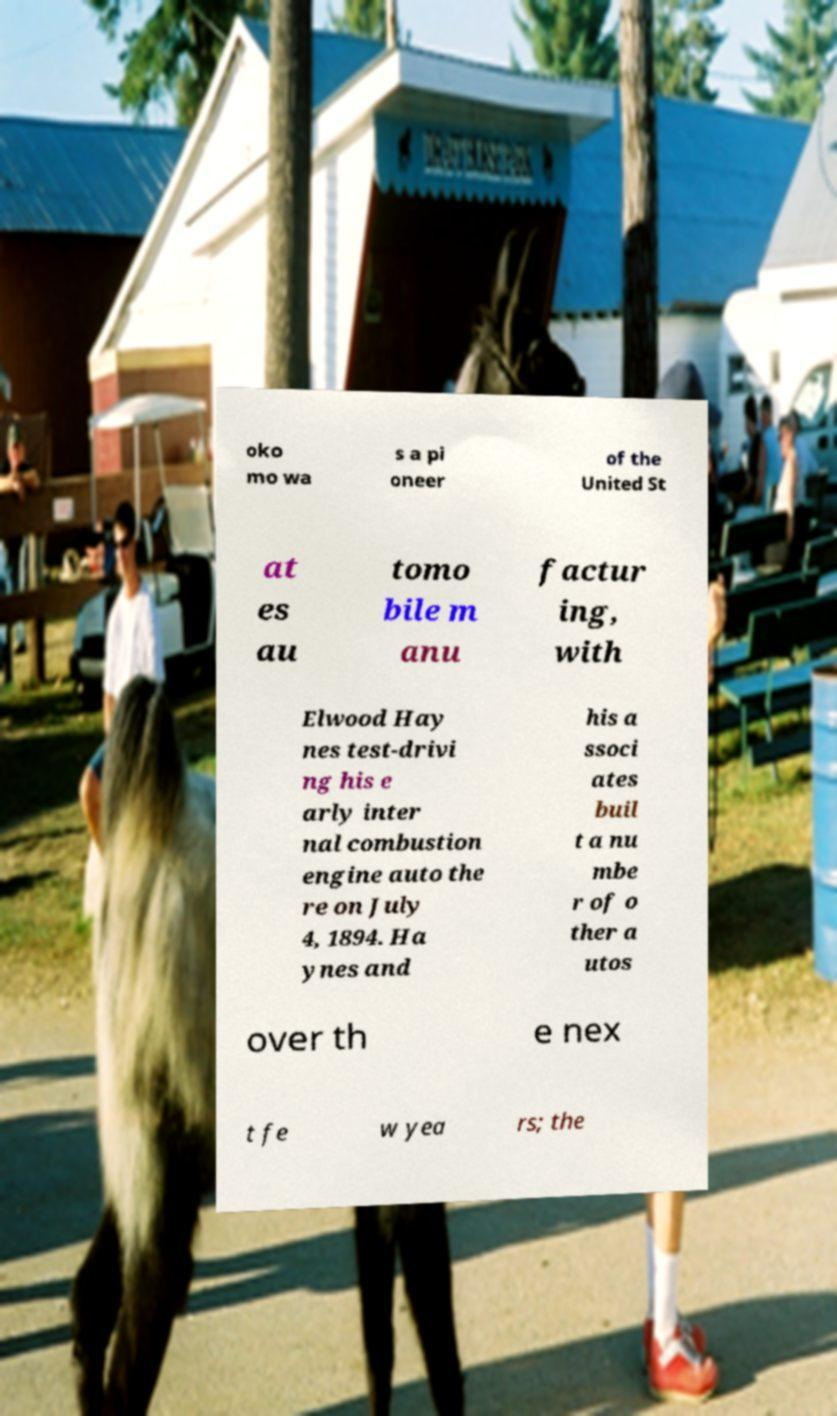Can you accurately transcribe the text from the provided image for me? oko mo wa s a pi oneer of the United St at es au tomo bile m anu factur ing, with Elwood Hay nes test-drivi ng his e arly inter nal combustion engine auto the re on July 4, 1894. Ha ynes and his a ssoci ates buil t a nu mbe r of o ther a utos over th e nex t fe w yea rs; the 